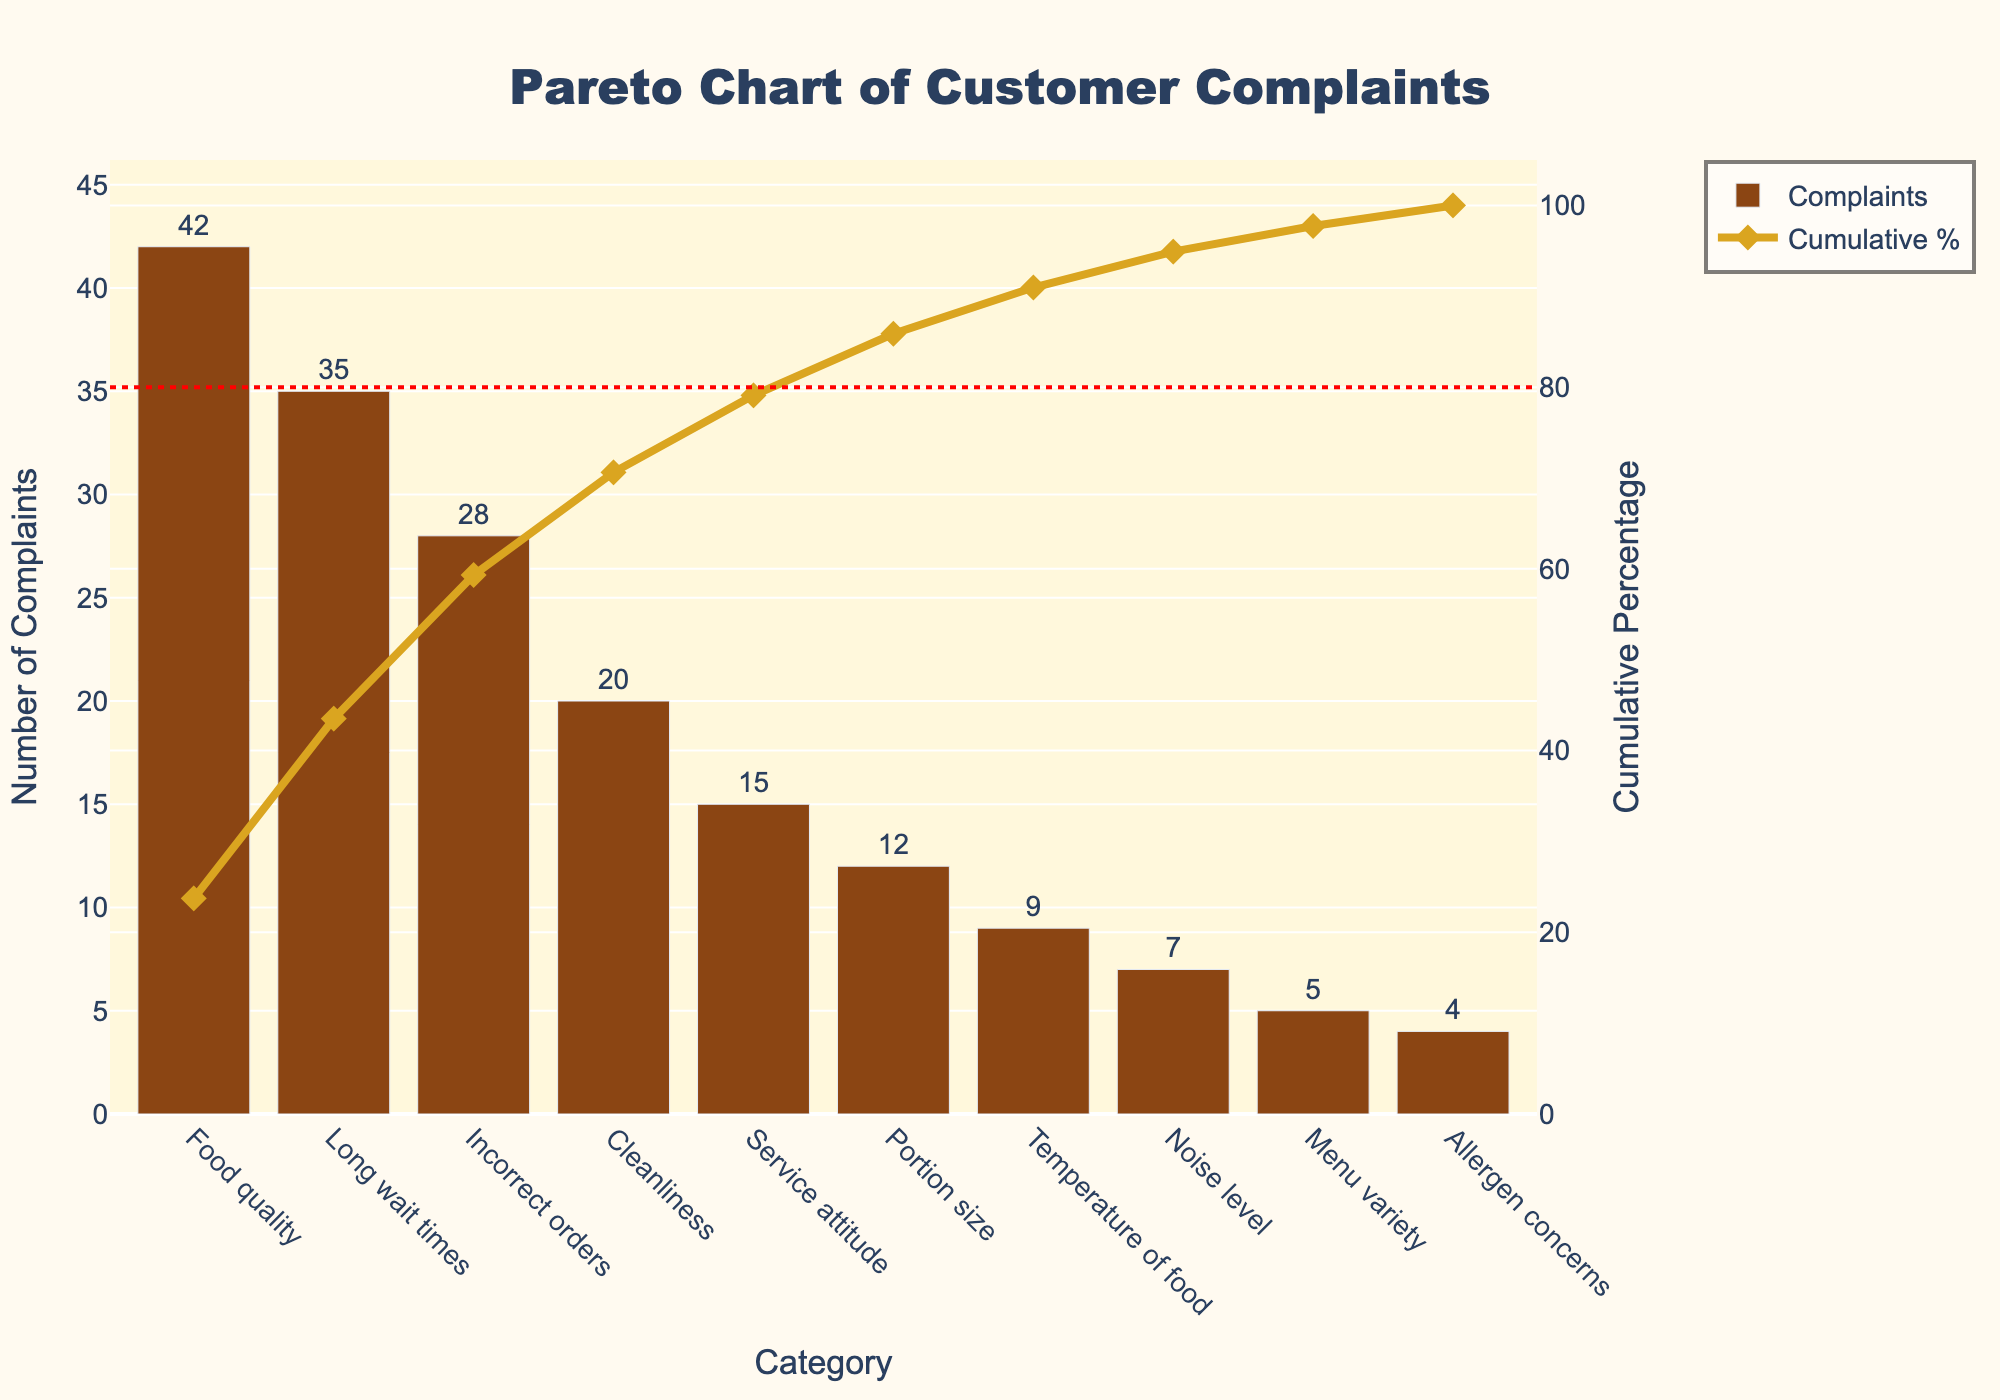What's the title of the figure? The title is prominently displayed at the top center of the figure.
Answer: Pareto Chart of Customer Complaints Which category has the highest number of complaints? The bar with the highest value indicates the category with the most complaints.
Answer: Food quality What is the cumulative percentage after considering the top three complaint categories? To find the cumulative percentage, add the complaints from the top three categories and then refer to the corresponding cumulative percentage on the secondary y-axis. The top three categories are "Food quality" (42), "Long wait times" (35), and "Incorrect orders" (28). The combined total is 42 + 35 + 28 = 105. The cumulative percentage at this point from the y-axis marked "Cumulative Percentage" is approximately 67%.
Answer: Approximately 67% How many categories account for 80% of the cumulative percentage? Identify where the 80% reference line intersects the cumulative percentage line and count the corresponding categories up to that point.
Answer: Eight categories Which complaint category is just below the 80% cumulative percentage mark? Locate where the cumulative percentage curve crosses right before the 80% reference line. The category at this position is "Temperature of food."
Answer: Temperature of food What is the exact number of complaints for "Menu variety"? Locate the bar corresponding to "Menu variety" and read the value displayed next to it.
Answer: 5 How many complaints are there in total? Sum the values of all bars representing each category. The values are 42 + 35 + 28 + 20 + 15 + 12 + 9 + 7 + 5 + 4 = 177.
Answer: 177 For which categories does the cumulative percentage increase by more than 10%? Calculate the difference in cumulative percentages between subsequent categories and check which increments are greater than 10%. From "Food quality" (23.73%), "Long wait times" (20%), and "Incorrect orders" (15.82%) all show increases above 10%.
Answer: Food quality, Long wait times, Incorrect orders What percentage of total complaints does the "Long wait times" category represent? The percentage can be calculated by dividing the number of complaints for "Long wait times" by the total number and multiplying by 100: (35/177) × 100 ≈ 19.77%.
Answer: Approximately 19.77% Which categories fall entirely above the 80% reference line? The categories that appear after the 80% cumulative line mark should be counted. These are "Noise level," "Menu variety," and "Allergen concerns."
Answer: Noise level, Menu variety, Allergen concerns 